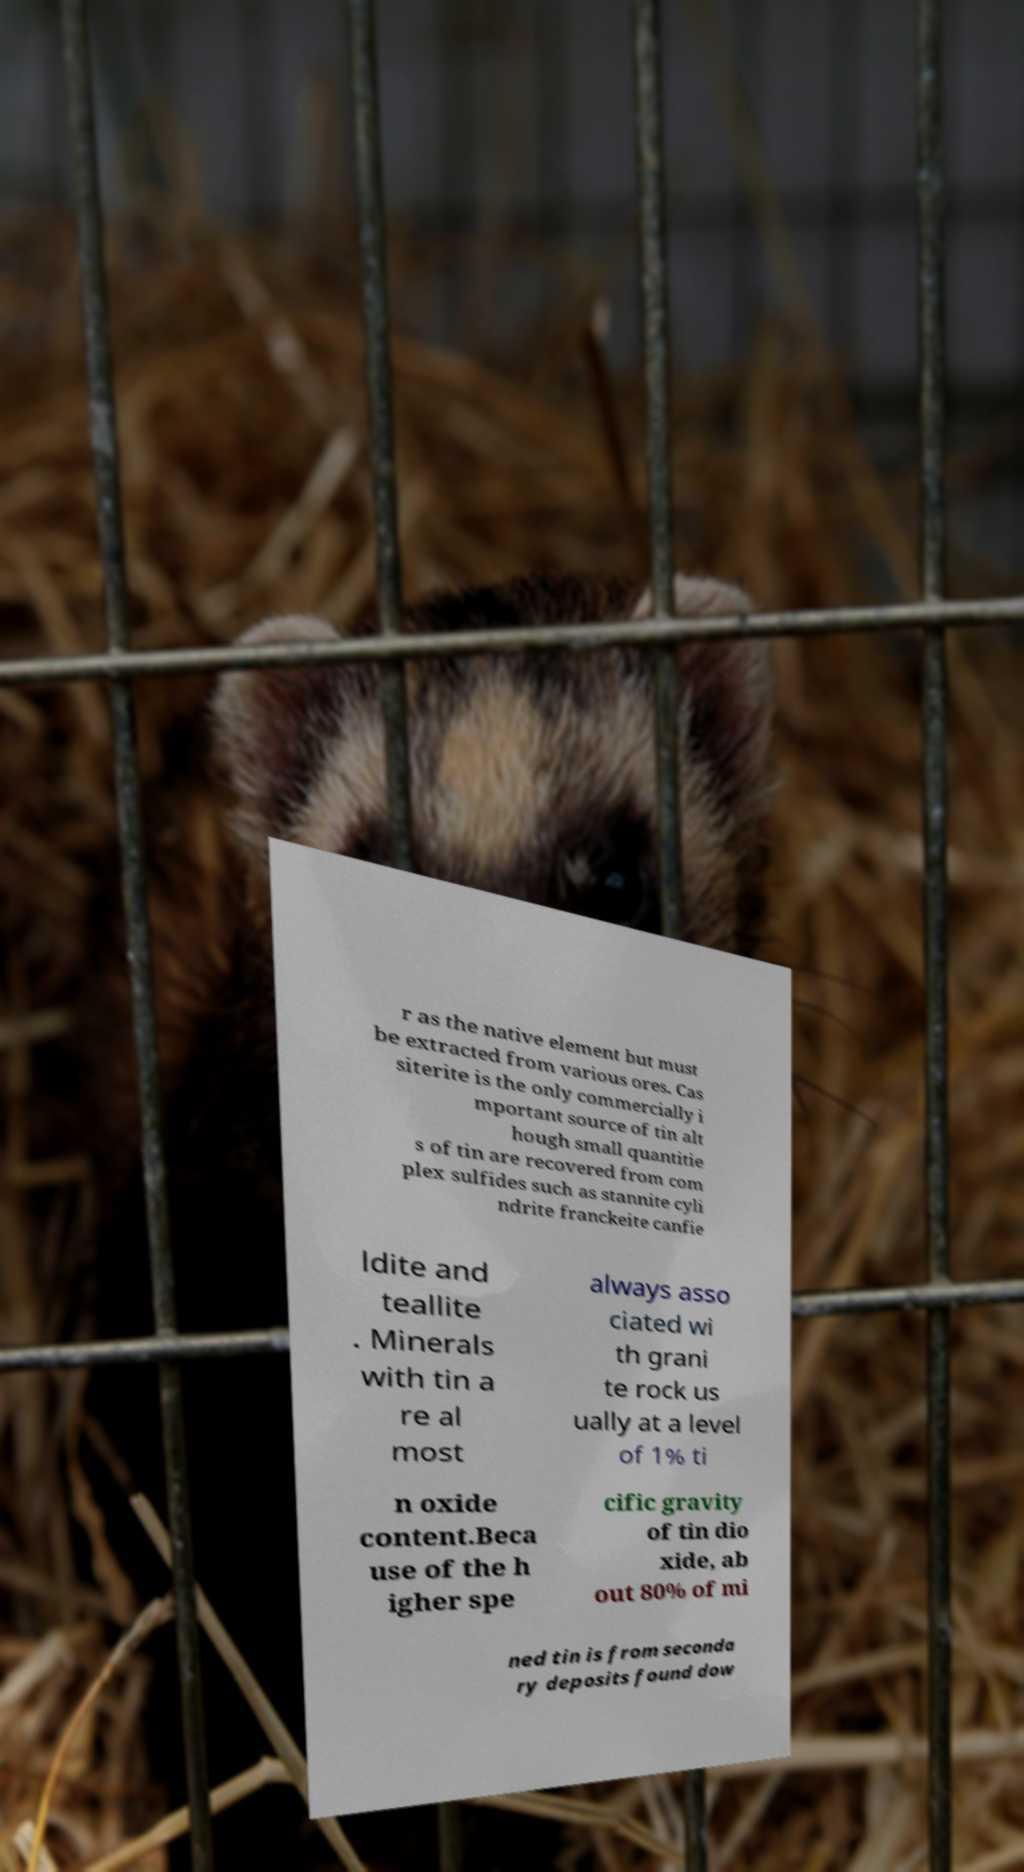Can you read and provide the text displayed in the image?This photo seems to have some interesting text. Can you extract and type it out for me? r as the native element but must be extracted from various ores. Cas siterite is the only commercially i mportant source of tin alt hough small quantitie s of tin are recovered from com plex sulfides such as stannite cyli ndrite franckeite canfie ldite and teallite . Minerals with tin a re al most always asso ciated wi th grani te rock us ually at a level of 1% ti n oxide content.Beca use of the h igher spe cific gravity of tin dio xide, ab out 80% of mi ned tin is from seconda ry deposits found dow 